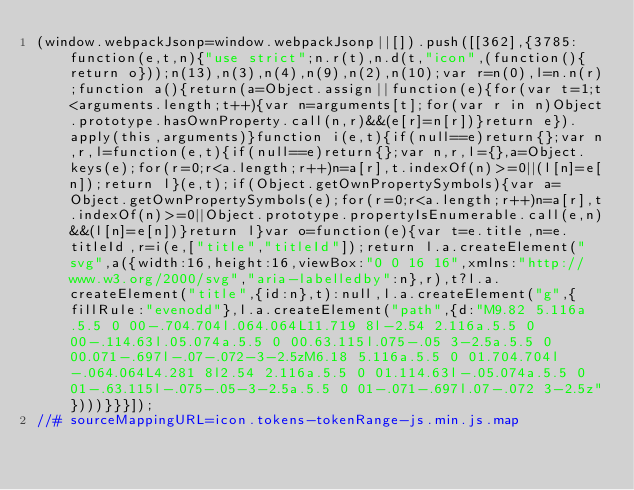Convert code to text. <code><loc_0><loc_0><loc_500><loc_500><_JavaScript_>(window.webpackJsonp=window.webpackJsonp||[]).push([[362],{3785:function(e,t,n){"use strict";n.r(t),n.d(t,"icon",(function(){return o}));n(13),n(3),n(4),n(9),n(2),n(10);var r=n(0),l=n.n(r);function a(){return(a=Object.assign||function(e){for(var t=1;t<arguments.length;t++){var n=arguments[t];for(var r in n)Object.prototype.hasOwnProperty.call(n,r)&&(e[r]=n[r])}return e}).apply(this,arguments)}function i(e,t){if(null==e)return{};var n,r,l=function(e,t){if(null==e)return{};var n,r,l={},a=Object.keys(e);for(r=0;r<a.length;r++)n=a[r],t.indexOf(n)>=0||(l[n]=e[n]);return l}(e,t);if(Object.getOwnPropertySymbols){var a=Object.getOwnPropertySymbols(e);for(r=0;r<a.length;r++)n=a[r],t.indexOf(n)>=0||Object.prototype.propertyIsEnumerable.call(e,n)&&(l[n]=e[n])}return l}var o=function(e){var t=e.title,n=e.titleId,r=i(e,["title","titleId"]);return l.a.createElement("svg",a({width:16,height:16,viewBox:"0 0 16 16",xmlns:"http://www.w3.org/2000/svg","aria-labelledby":n},r),t?l.a.createElement("title",{id:n},t):null,l.a.createElement("g",{fillRule:"evenodd"},l.a.createElement("path",{d:"M9.82 5.116a.5.5 0 00-.704.704l.064.064L11.719 8l-2.54 2.116a.5.5 0 00-.114.63l.05.074a.5.5 0 00.63.115l.075-.05 3-2.5a.5.5 0 00.071-.697l-.07-.072-3-2.5zM6.18 5.116a.5.5 0 01.704.704l-.064.064L4.281 8l2.54 2.116a.5.5 0 01.114.63l-.05.074a.5.5 0 01-.63.115l-.075-.05-3-2.5a.5.5 0 01-.071-.697l.07-.072 3-2.5z"})))}}}]);
//# sourceMappingURL=icon.tokens-tokenRange-js.min.js.map</code> 